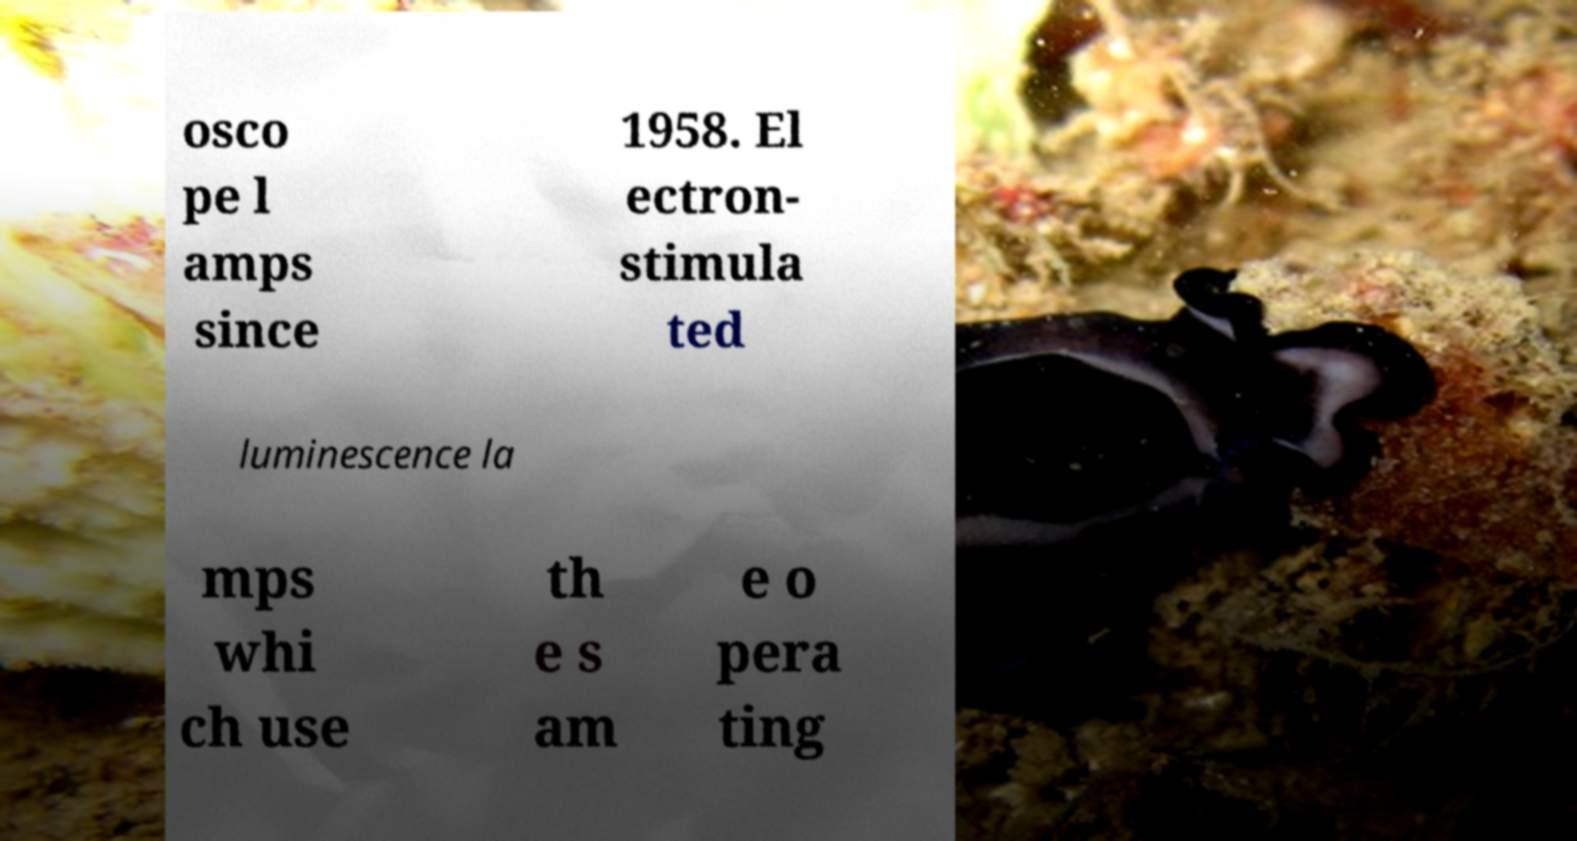Could you extract and type out the text from this image? osco pe l amps since 1958. El ectron- stimula ted luminescence la mps whi ch use th e s am e o pera ting 